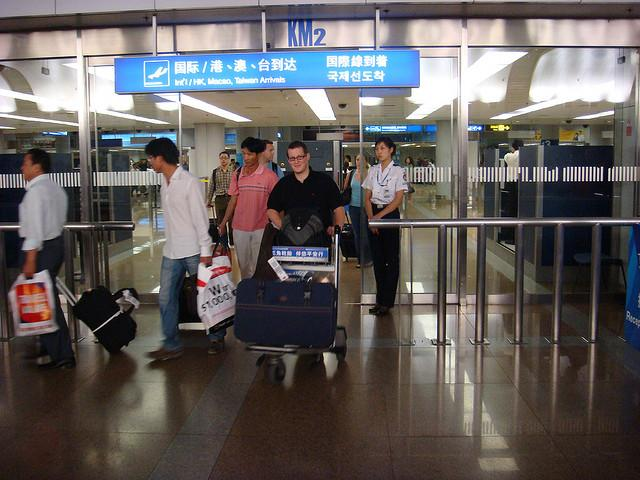What language is the sign in?

Choices:
A) english
B) chinese
C) egyptian
D) french chinese 